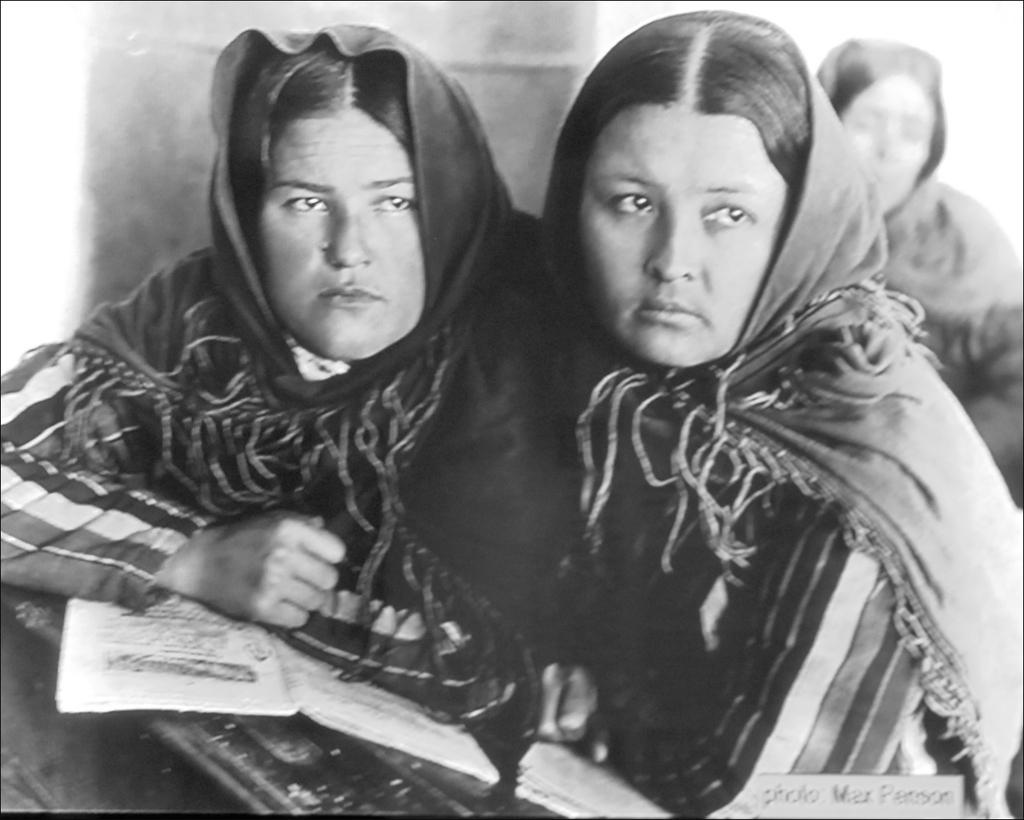What type of picture is in the image? There is a black and white picture in the image. Who or what is depicted in the picture? The picture contains two women. What are the women wearing in the picture? The women are wearing clothes. What else can be seen in the image besides the picture? There are books visible in the image. Are there any other people in the image besides the two women? Yes, there is another person wearing clothes in the image. What type of vegetable is being used as a prop in the image? There is no vegetable present in the image. How does the person in the image say good-bye to the two women? There is no indication of anyone saying good-bye in the image. 